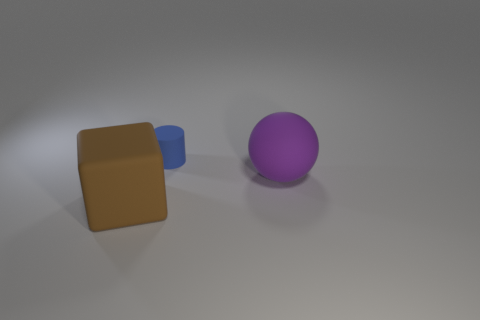Add 3 large purple balls. How many objects exist? 6 Subtract all balls. How many objects are left? 2 Subtract all red cubes. Subtract all purple cylinders. How many cubes are left? 1 Subtract all brown blocks. How many purple cylinders are left? 0 Subtract all red rubber cylinders. Subtract all large things. How many objects are left? 1 Add 2 large purple rubber balls. How many large purple rubber balls are left? 3 Add 1 tiny gray objects. How many tiny gray objects exist? 1 Subtract 0 cyan spheres. How many objects are left? 3 Subtract 1 cubes. How many cubes are left? 0 